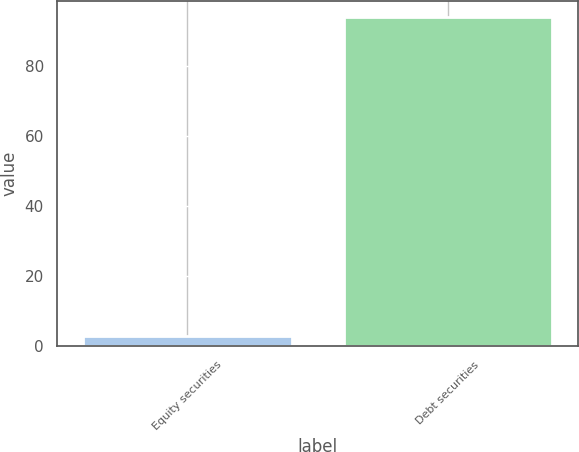Convert chart. <chart><loc_0><loc_0><loc_500><loc_500><bar_chart><fcel>Equity securities<fcel>Debt securities<nl><fcel>3<fcel>94<nl></chart> 